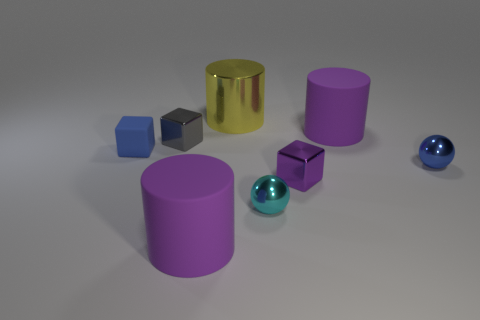Subtract all big yellow cylinders. How many cylinders are left? 2 Add 2 purple cubes. How many objects exist? 10 Subtract 2 spheres. How many spheres are left? 0 Subtract all yellow cylinders. How many cylinders are left? 2 Subtract all gray spheres. How many purple cubes are left? 1 Subtract all cylinders. How many objects are left? 5 Subtract all purple balls. Subtract all cyan cylinders. How many balls are left? 2 Subtract all purple cylinders. Subtract all small blue metallic balls. How many objects are left? 5 Add 5 small cyan metal objects. How many small cyan metal objects are left? 6 Add 7 tiny cyan shiny objects. How many tiny cyan shiny objects exist? 8 